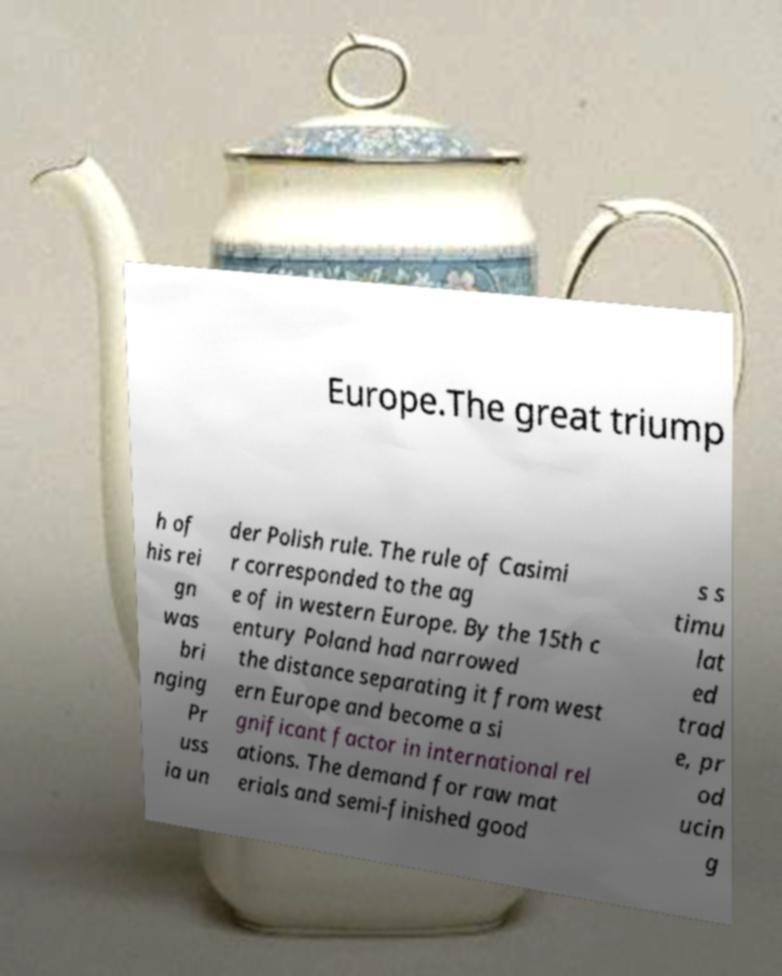Could you assist in decoding the text presented in this image and type it out clearly? Europe.The great triump h of his rei gn was bri nging Pr uss ia un der Polish rule. The rule of Casimi r corresponded to the ag e of in western Europe. By the 15th c entury Poland had narrowed the distance separating it from west ern Europe and become a si gnificant factor in international rel ations. The demand for raw mat erials and semi-finished good s s timu lat ed trad e, pr od ucin g 